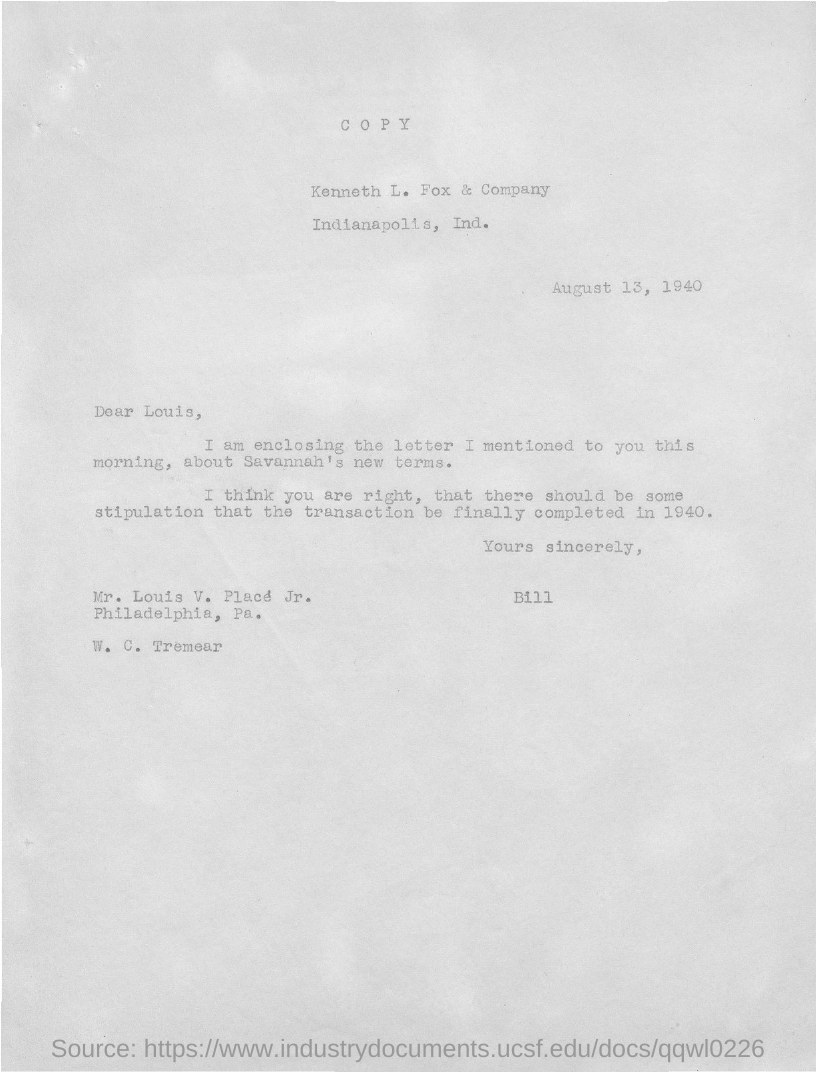Specify some key components in this picture. The recipient of this letter is Louis. The writer of this letter is Bill. The letter was dated August 13, 1940. 